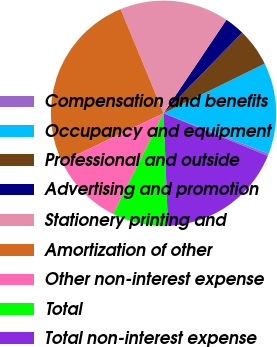<chart> <loc_0><loc_0><loc_500><loc_500><pie_chart><fcel>Compensation and benefits<fcel>Occupancy and equipment<fcel>Professional and outside<fcel>Advertising and promotion<fcel>Stationery printing and<fcel>Amortization of other<fcel>Other non-interest expense<fcel>Total<fcel>Total non-interest expense<nl><fcel>0.33%<fcel>13.1%<fcel>5.44%<fcel>2.88%<fcel>15.65%<fcel>25.86%<fcel>10.54%<fcel>7.99%<fcel>18.2%<nl></chart> 